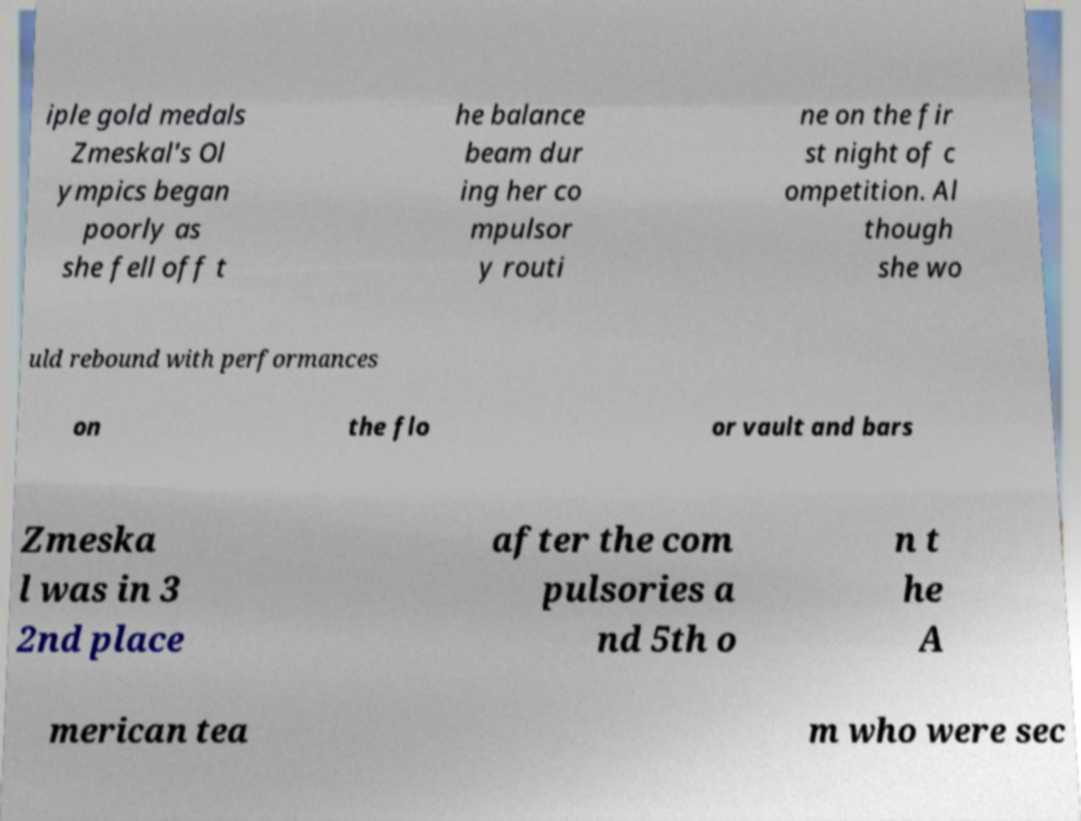Can you accurately transcribe the text from the provided image for me? iple gold medals Zmeskal's Ol ympics began poorly as she fell off t he balance beam dur ing her co mpulsor y routi ne on the fir st night of c ompetition. Al though she wo uld rebound with performances on the flo or vault and bars Zmeska l was in 3 2nd place after the com pulsories a nd 5th o n t he A merican tea m who were sec 